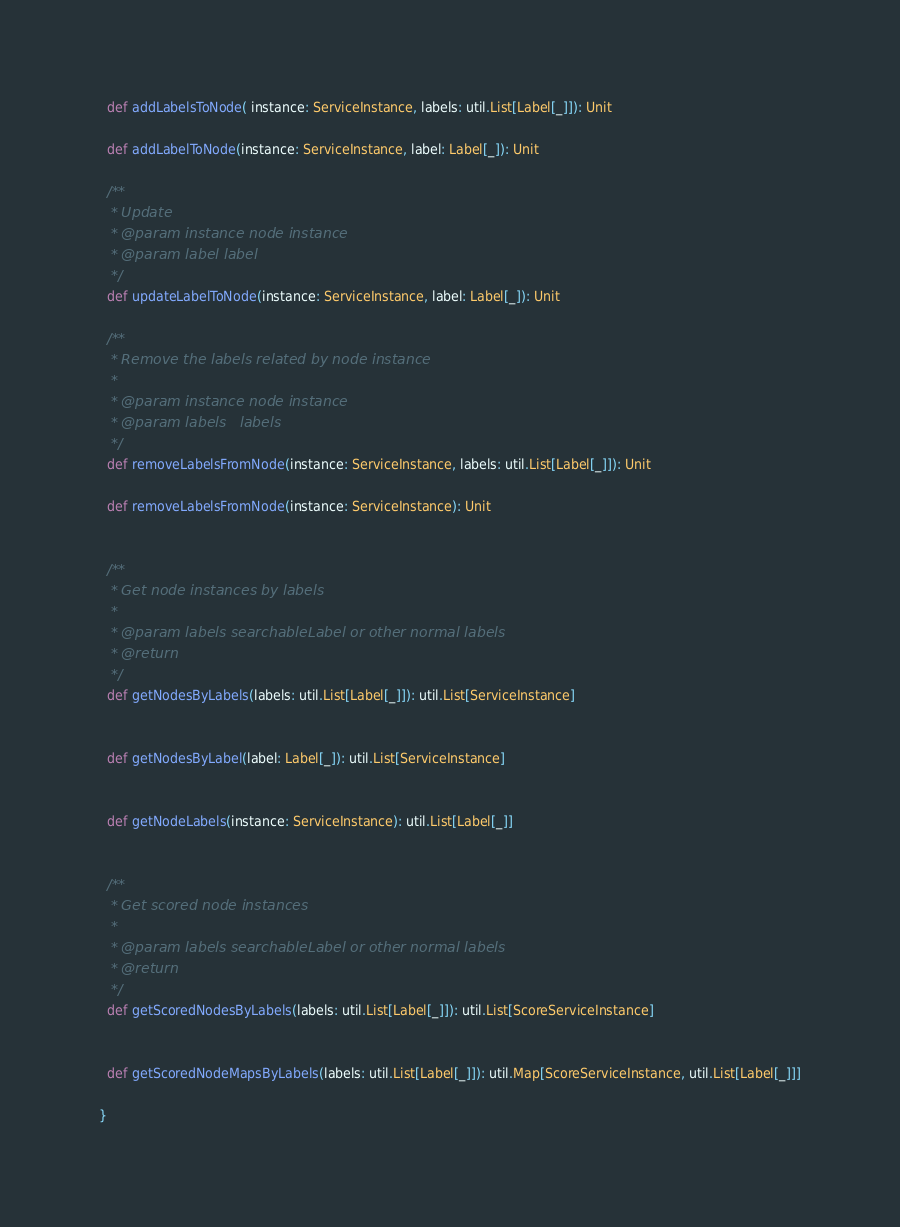<code> <loc_0><loc_0><loc_500><loc_500><_Scala_>  def addLabelsToNode( instance: ServiceInstance, labels: util.List[Label[_]]): Unit

  def addLabelToNode(instance: ServiceInstance, label: Label[_]): Unit

  /**
   * Update
   * @param instance node instance
   * @param label label
   */
  def updateLabelToNode(instance: ServiceInstance, label: Label[_]): Unit

  /**
   * Remove the labels related by node instance
   *
   * @param instance node instance
   * @param labels   labels
   */
  def removeLabelsFromNode(instance: ServiceInstance, labels: util.List[Label[_]]): Unit

  def removeLabelsFromNode(instance: ServiceInstance): Unit


  /**
   * Get node instances by labels
   *
   * @param labels searchableLabel or other normal labels
   * @return
   */
  def getNodesByLabels(labels: util.List[Label[_]]): util.List[ServiceInstance]


  def getNodesByLabel(label: Label[_]): util.List[ServiceInstance]


  def getNodeLabels(instance: ServiceInstance): util.List[Label[_]]


  /**
   * Get scored node instances
   *
   * @param labels searchableLabel or other normal labels
   * @return
   */
  def getScoredNodesByLabels(labels: util.List[Label[_]]): util.List[ScoreServiceInstance]


  def getScoredNodeMapsByLabels(labels: util.List[Label[_]]): util.Map[ScoreServiceInstance, util.List[Label[_]]]

}
</code> 